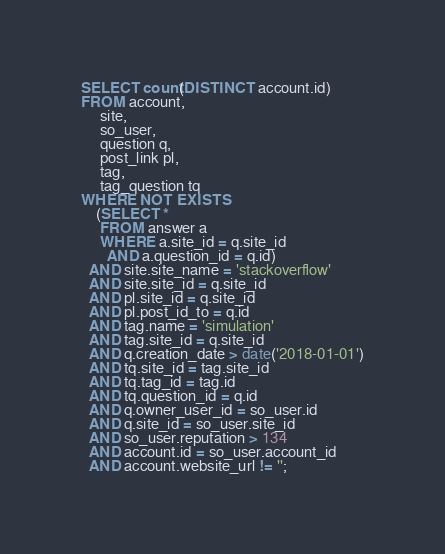Convert code to text. <code><loc_0><loc_0><loc_500><loc_500><_SQL_>
SELECT count(DISTINCT account.id)
FROM account,
     site,
     so_user,
     question q,
     post_link pl,
     tag,
     tag_question tq
WHERE NOT EXISTS
    (SELECT *
     FROM answer a
     WHERE a.site_id = q.site_id
       AND a.question_id = q.id)
  AND site.site_name = 'stackoverflow'
  AND site.site_id = q.site_id
  AND pl.site_id = q.site_id
  AND pl.post_id_to = q.id
  AND tag.name = 'simulation'
  AND tag.site_id = q.site_id
  AND q.creation_date > date('2018-01-01')
  AND tq.site_id = tag.site_id
  AND tq.tag_id = tag.id
  AND tq.question_id = q.id
  AND q.owner_user_id = so_user.id
  AND q.site_id = so_user.site_id
  AND so_user.reputation > 134
  AND account.id = so_user.account_id
  AND account.website_url != '';</code> 